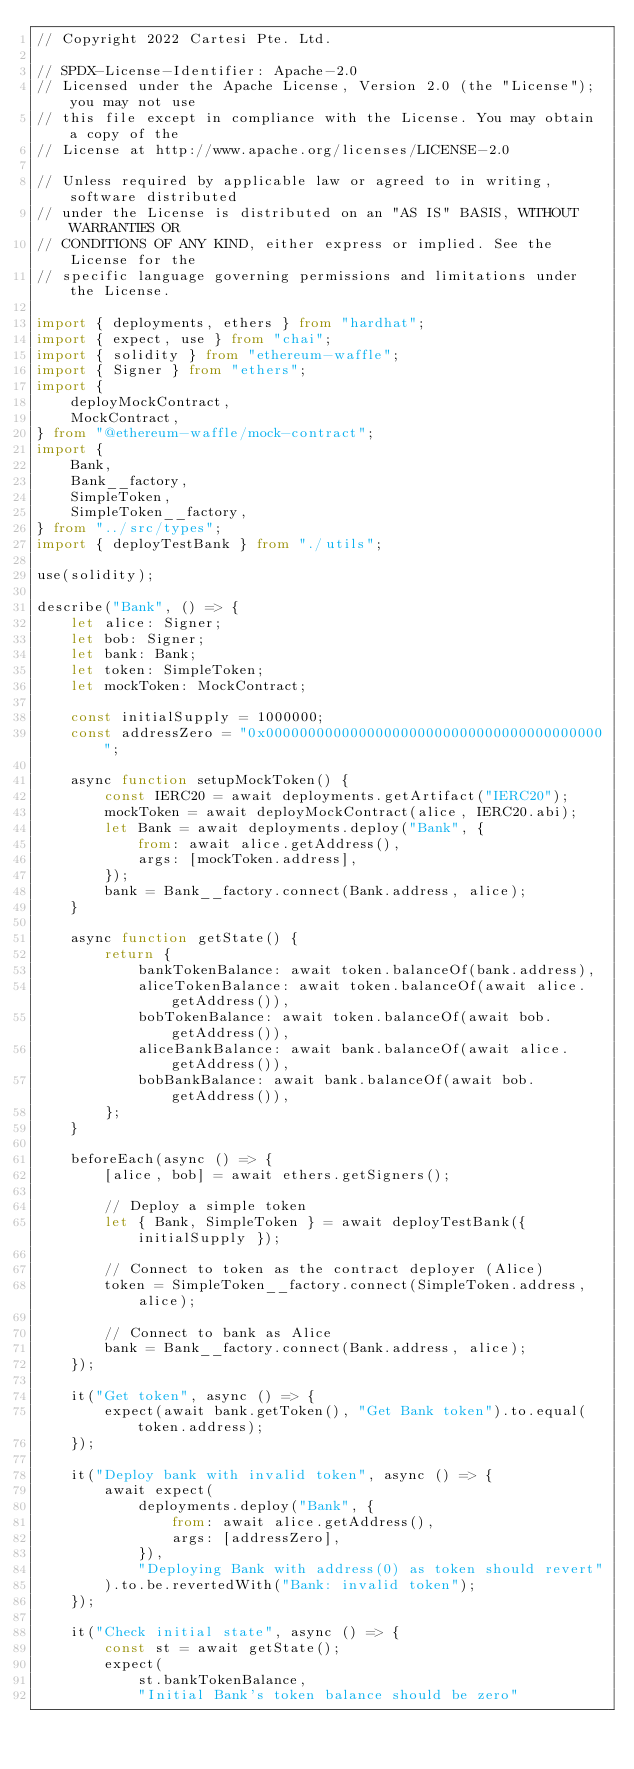<code> <loc_0><loc_0><loc_500><loc_500><_TypeScript_>// Copyright 2022 Cartesi Pte. Ltd.

// SPDX-License-Identifier: Apache-2.0
// Licensed under the Apache License, Version 2.0 (the "License"); you may not use
// this file except in compliance with the License. You may obtain a copy of the
// License at http://www.apache.org/licenses/LICENSE-2.0

// Unless required by applicable law or agreed to in writing, software distributed
// under the License is distributed on an "AS IS" BASIS, WITHOUT WARRANTIES OR
// CONDITIONS OF ANY KIND, either express or implied. See the License for the
// specific language governing permissions and limitations under the License.

import { deployments, ethers } from "hardhat";
import { expect, use } from "chai";
import { solidity } from "ethereum-waffle";
import { Signer } from "ethers";
import {
    deployMockContract,
    MockContract,
} from "@ethereum-waffle/mock-contract";
import {
    Bank,
    Bank__factory,
    SimpleToken,
    SimpleToken__factory,
} from "../src/types";
import { deployTestBank } from "./utils";

use(solidity);

describe("Bank", () => {
    let alice: Signer;
    let bob: Signer;
    let bank: Bank;
    let token: SimpleToken;
    let mockToken: MockContract;

    const initialSupply = 1000000;
    const addressZero = "0x0000000000000000000000000000000000000000";

    async function setupMockToken() {
        const IERC20 = await deployments.getArtifact("IERC20");
        mockToken = await deployMockContract(alice, IERC20.abi);
        let Bank = await deployments.deploy("Bank", {
            from: await alice.getAddress(),
            args: [mockToken.address],
        });
        bank = Bank__factory.connect(Bank.address, alice);
    }

    async function getState() {
        return {
            bankTokenBalance: await token.balanceOf(bank.address),
            aliceTokenBalance: await token.balanceOf(await alice.getAddress()),
            bobTokenBalance: await token.balanceOf(await bob.getAddress()),
            aliceBankBalance: await bank.balanceOf(await alice.getAddress()),
            bobBankBalance: await bank.balanceOf(await bob.getAddress()),
        };
    }

    beforeEach(async () => {
        [alice, bob] = await ethers.getSigners();

        // Deploy a simple token
        let { Bank, SimpleToken } = await deployTestBank({ initialSupply });

        // Connect to token as the contract deployer (Alice)
        token = SimpleToken__factory.connect(SimpleToken.address, alice);

        // Connect to bank as Alice
        bank = Bank__factory.connect(Bank.address, alice);
    });

    it("Get token", async () => {
        expect(await bank.getToken(), "Get Bank token").to.equal(token.address);
    });

    it("Deploy bank with invalid token", async () => {
        await expect(
            deployments.deploy("Bank", {
                from: await alice.getAddress(),
                args: [addressZero],
            }),
            "Deploying Bank with address(0) as token should revert"
        ).to.be.revertedWith("Bank: invalid token");
    });

    it("Check initial state", async () => {
        const st = await getState();
        expect(
            st.bankTokenBalance,
            "Initial Bank's token balance should be zero"</code> 